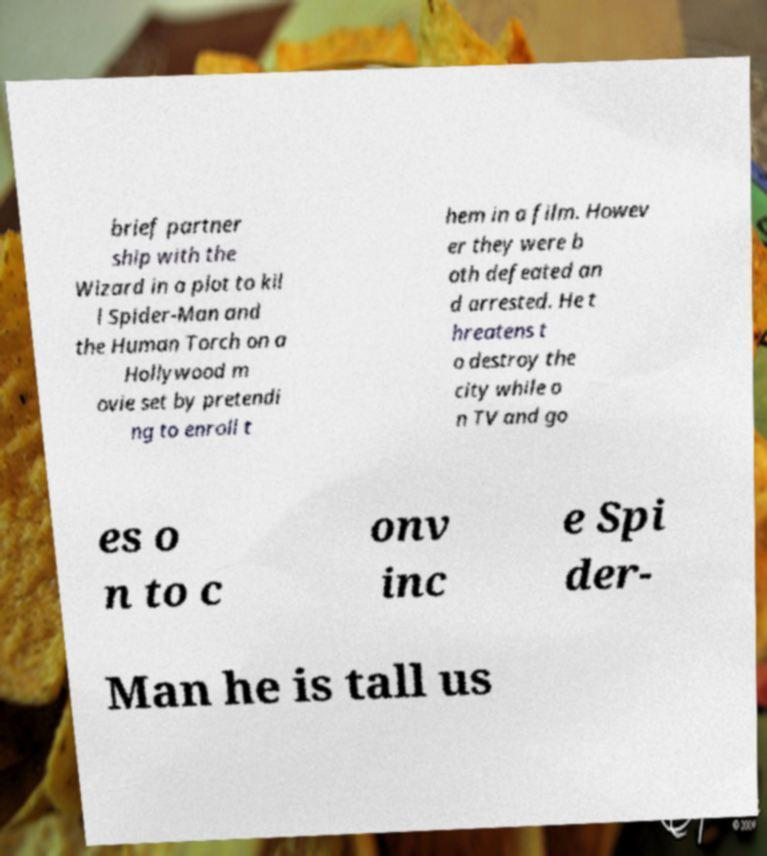Please read and relay the text visible in this image. What does it say? brief partner ship with the Wizard in a plot to kil l Spider-Man and the Human Torch on a Hollywood m ovie set by pretendi ng to enroll t hem in a film. Howev er they were b oth defeated an d arrested. He t hreatens t o destroy the city while o n TV and go es o n to c onv inc e Spi der- Man he is tall us 